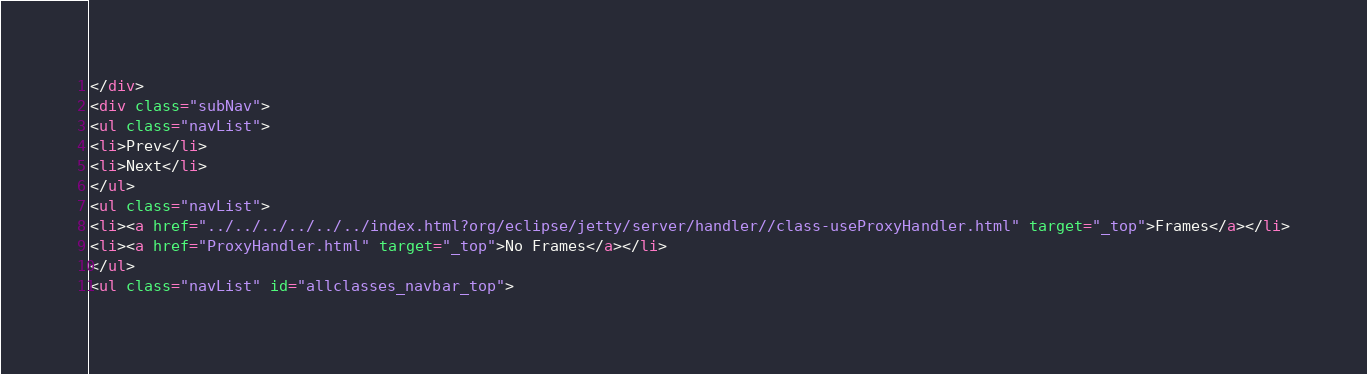Convert code to text. <code><loc_0><loc_0><loc_500><loc_500><_HTML_></div>
<div class="subNav">
<ul class="navList">
<li>Prev</li>
<li>Next</li>
</ul>
<ul class="navList">
<li><a href="../../../../../../index.html?org/eclipse/jetty/server/handler//class-useProxyHandler.html" target="_top">Frames</a></li>
<li><a href="ProxyHandler.html" target="_top">No Frames</a></li>
</ul>
<ul class="navList" id="allclasses_navbar_top"></code> 